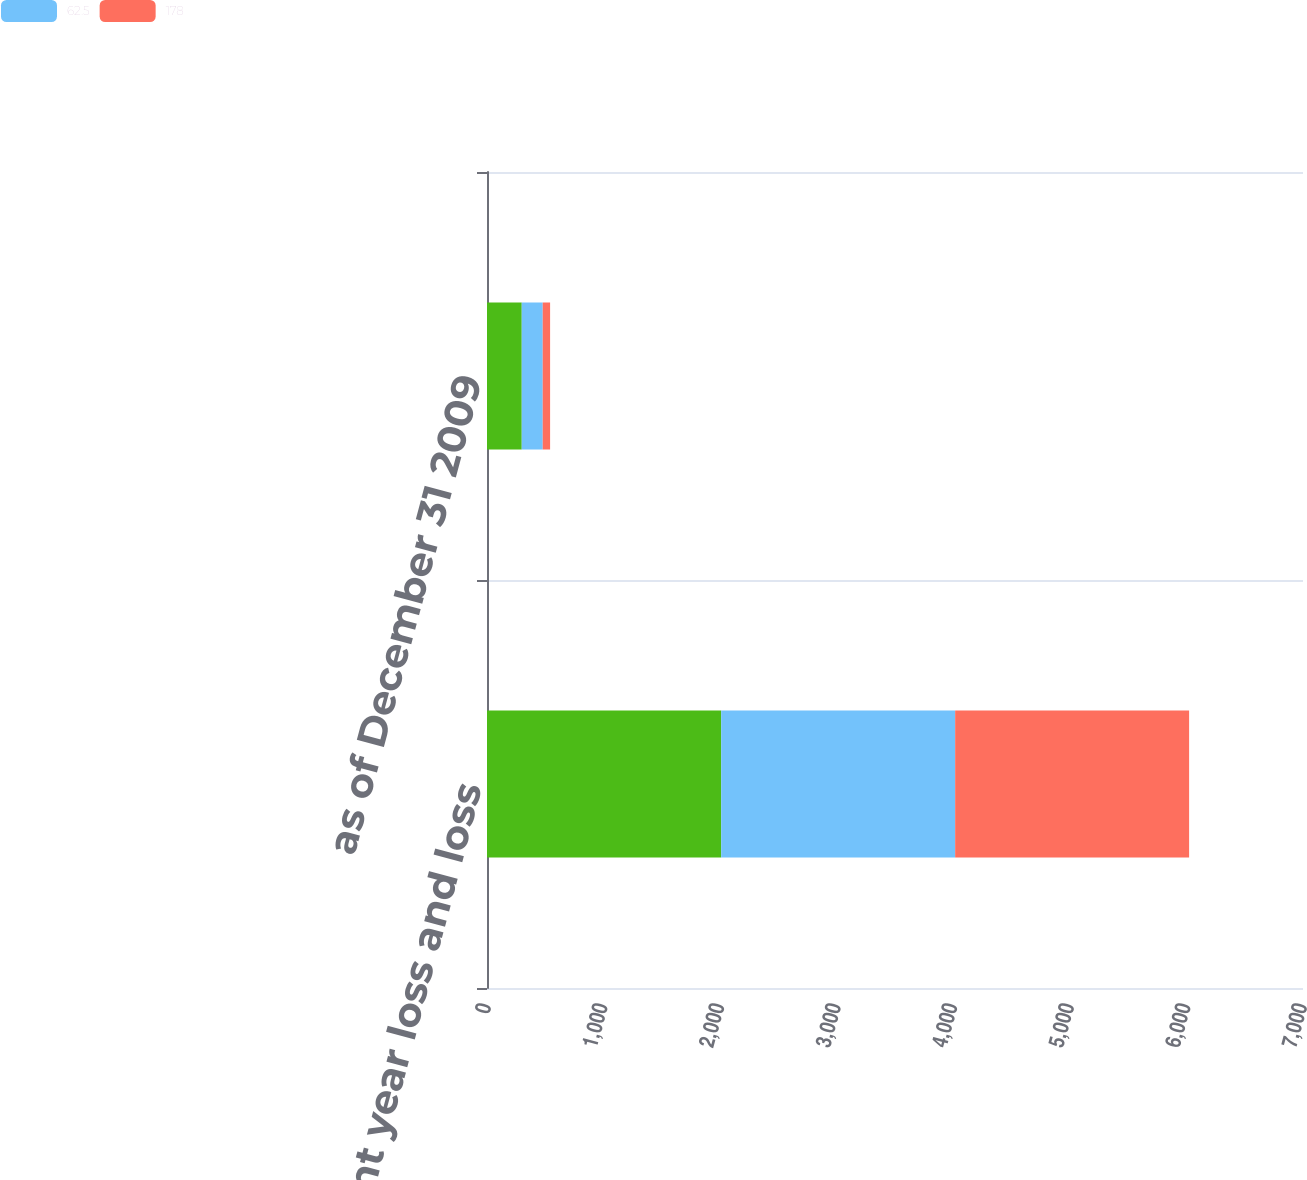Convert chart to OTSL. <chart><loc_0><loc_0><loc_500><loc_500><stacked_bar_chart><ecel><fcel>Accident year loss and loss<fcel>as of December 31 2009<nl><fcel>nan<fcel>2009<fcel>298<nl><fcel>62.5<fcel>2007<fcel>180<nl><fcel>178<fcel>2007<fcel>63.3<nl></chart> 